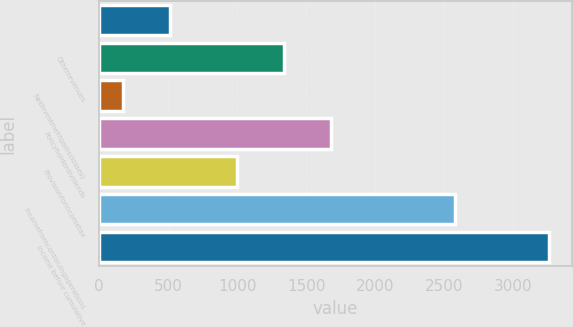<chart> <loc_0><loc_0><loc_500><loc_500><bar_chart><ecel><fcel>Otherrevenues<fcel>Netinvestmentgains(losses)<fcel>Policyholderdividends<fcel>Provisionforincometax<fcel>Incomefromcontinuingoperations<fcel>Income before cumulative<nl><fcel>514.9<fcel>1335.9<fcel>175<fcel>1675.8<fcel>996<fcel>2578<fcel>3257.8<nl></chart> 